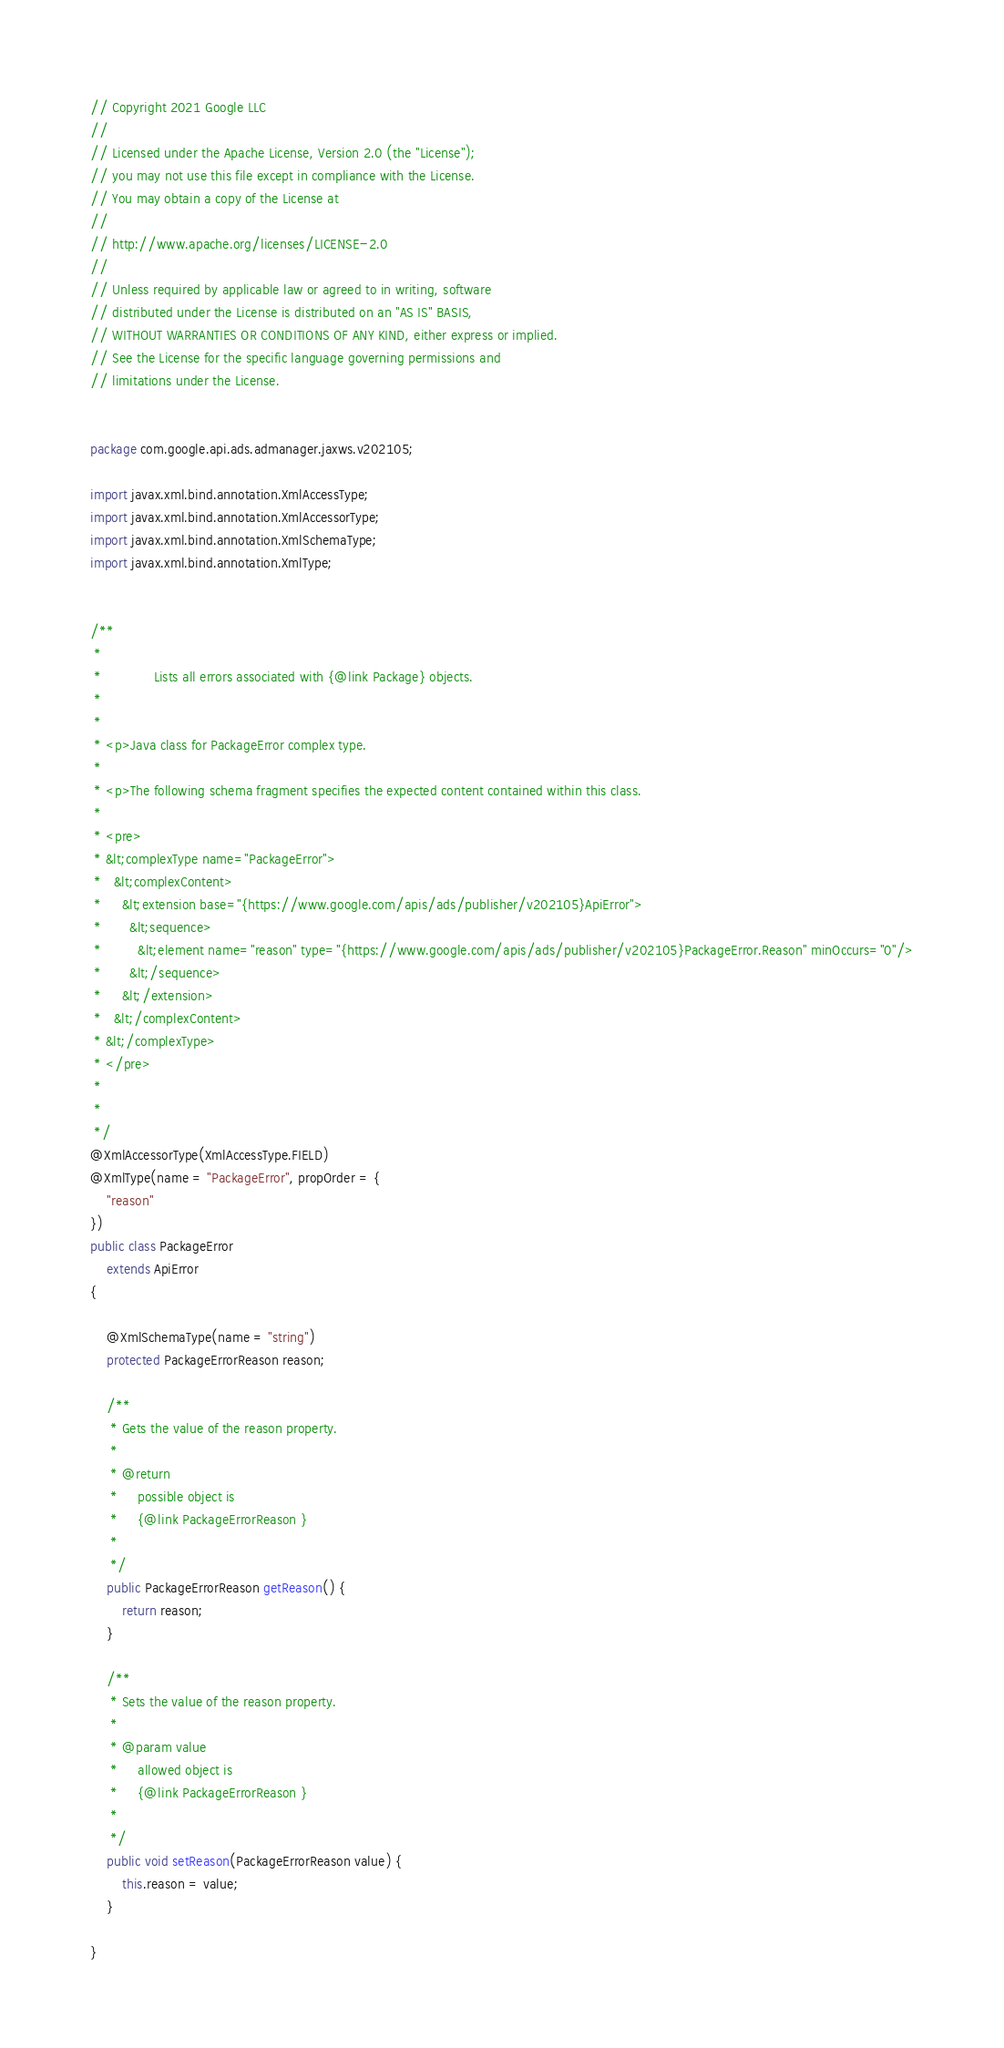<code> <loc_0><loc_0><loc_500><loc_500><_Java_>// Copyright 2021 Google LLC
//
// Licensed under the Apache License, Version 2.0 (the "License");
// you may not use this file except in compliance with the License.
// You may obtain a copy of the License at
//
// http://www.apache.org/licenses/LICENSE-2.0
//
// Unless required by applicable law or agreed to in writing, software
// distributed under the License is distributed on an "AS IS" BASIS,
// WITHOUT WARRANTIES OR CONDITIONS OF ANY KIND, either express or implied.
// See the License for the specific language governing permissions and
// limitations under the License.


package com.google.api.ads.admanager.jaxws.v202105;

import javax.xml.bind.annotation.XmlAccessType;
import javax.xml.bind.annotation.XmlAccessorType;
import javax.xml.bind.annotation.XmlSchemaType;
import javax.xml.bind.annotation.XmlType;


/**
 * 
 *             Lists all errors associated with {@link Package} objects.
 *           
 * 
 * <p>Java class for PackageError complex type.
 * 
 * <p>The following schema fragment specifies the expected content contained within this class.
 * 
 * <pre>
 * &lt;complexType name="PackageError">
 *   &lt;complexContent>
 *     &lt;extension base="{https://www.google.com/apis/ads/publisher/v202105}ApiError">
 *       &lt;sequence>
 *         &lt;element name="reason" type="{https://www.google.com/apis/ads/publisher/v202105}PackageError.Reason" minOccurs="0"/>
 *       &lt;/sequence>
 *     &lt;/extension>
 *   &lt;/complexContent>
 * &lt;/complexType>
 * </pre>
 * 
 * 
 */
@XmlAccessorType(XmlAccessType.FIELD)
@XmlType(name = "PackageError", propOrder = {
    "reason"
})
public class PackageError
    extends ApiError
{

    @XmlSchemaType(name = "string")
    protected PackageErrorReason reason;

    /**
     * Gets the value of the reason property.
     * 
     * @return
     *     possible object is
     *     {@link PackageErrorReason }
     *     
     */
    public PackageErrorReason getReason() {
        return reason;
    }

    /**
     * Sets the value of the reason property.
     * 
     * @param value
     *     allowed object is
     *     {@link PackageErrorReason }
     *     
     */
    public void setReason(PackageErrorReason value) {
        this.reason = value;
    }

}
</code> 